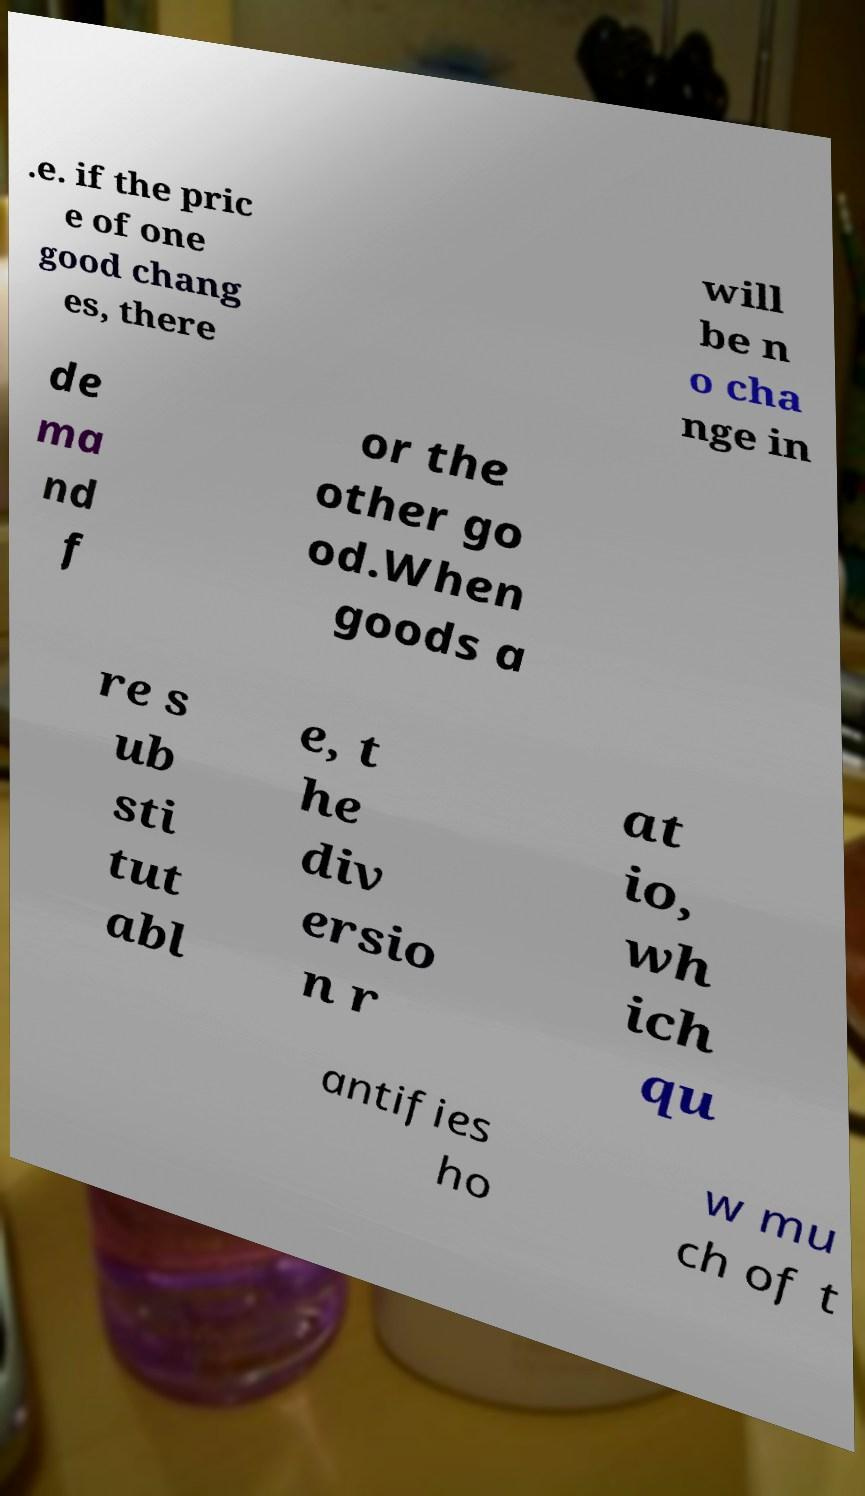Please read and relay the text visible in this image. What does it say? .e. if the pric e of one good chang es, there will be n o cha nge in de ma nd f or the other go od.When goods a re s ub sti tut abl e, t he div ersio n r at io, wh ich qu antifies ho w mu ch of t 